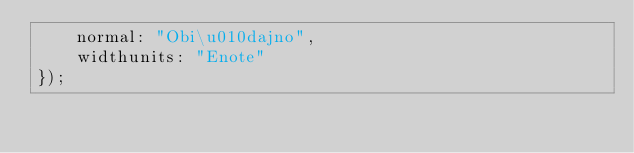<code> <loc_0><loc_0><loc_500><loc_500><_JavaScript_>    normal: "Obi\u010dajno",
    widthunits: "Enote"
});</code> 